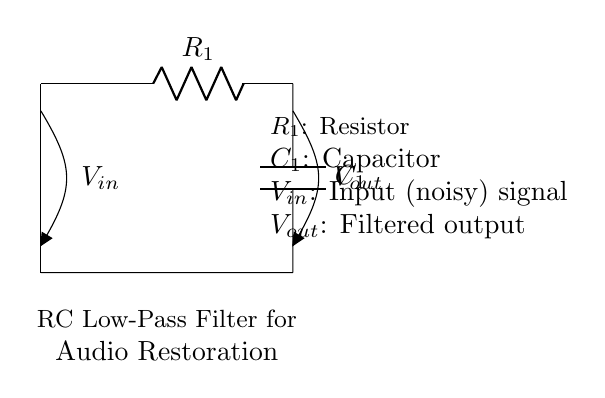What is the type of filter represented by the circuit? The circuit is an RC low-pass filter, which allows low-frequency signals to pass while attenuating high-frequency signals. This is indicated by the arrangement of the resistor and capacitor.
Answer: RC low-pass filter What does V-in represent in the circuit? V-in is the input signal which is described as noisy. It is the voltage applied at the input of the filter before any processing or filtering takes place.
Answer: Noisy input signal What component is labeled R1? R1 is the resistor in the circuit, which limits the current and impacts the time constant of the filter by working with the capacitor to filter the signals.
Answer: Resistor What is the purpose of the capacitor C1 in this circuit? The capacitor C1 stores and releases energy, helping to smooth out the variations in the input signal by slowing down changes in voltage, thereby filtering the higher frequency noise.
Answer: Energy storage How is the output voltage V-out defined in this circuit? V-out is the filtered output signal from the low-pass filter and is defined as the voltage across the capacitor C1 after it has processed the input signal.
Answer: Filtered output signal What impact does increasing R1 have on the circuit's behavior? Increasing R1 will increase the time constant of the filter (time constant = R1 * C1), which slows down the response of the circuit to changes in the input signal, leading to better attenuation of high-frequency noise.
Answer: Slower response 